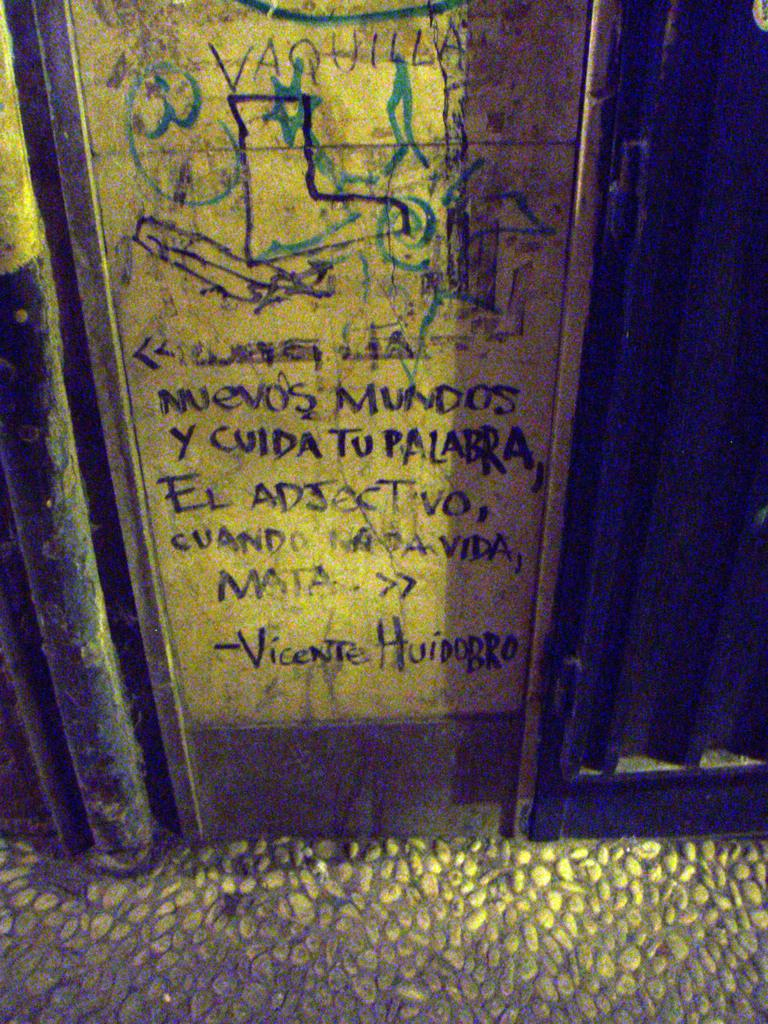<image>
Describe the image concisely. a wall that has the word vaquilla on it 